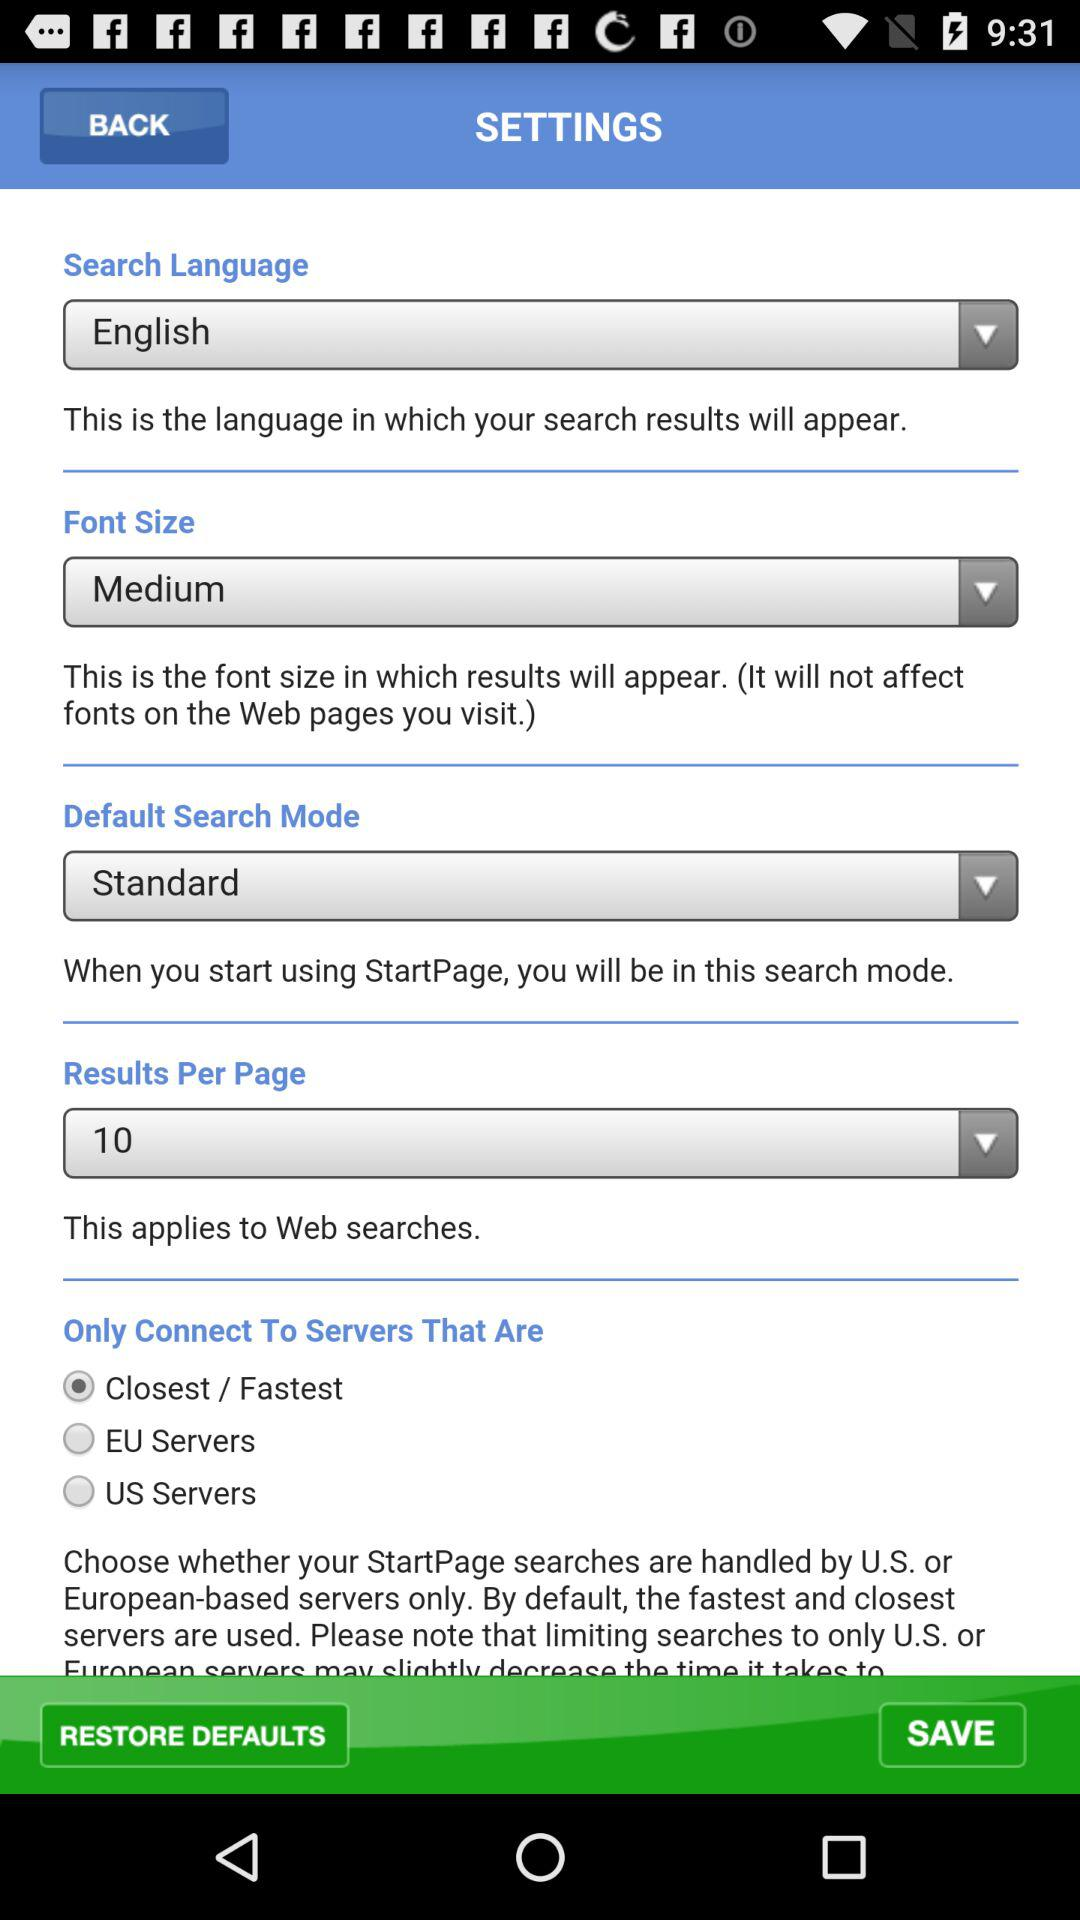Which is the search language? The search language is English. 